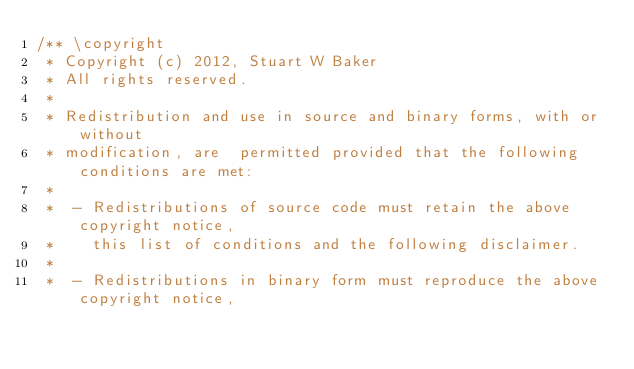<code> <loc_0><loc_0><loc_500><loc_500><_C++_>/** \copyright
 * Copyright (c) 2012, Stuart W Baker
 * All rights reserved.
 *
 * Redistribution and use in source and binary forms, with or without
 * modification, are  permitted provided that the following conditions are met:
 *
 *  - Redistributions of source code must retain the above copyright notice,
 *    this list of conditions and the following disclaimer.
 *
 *  - Redistributions in binary form must reproduce the above copyright notice,</code> 